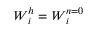<formula> <loc_0><loc_0><loc_500><loc_500>W _ { i } ^ { h } = W _ { i } ^ { n = 0 }</formula> 